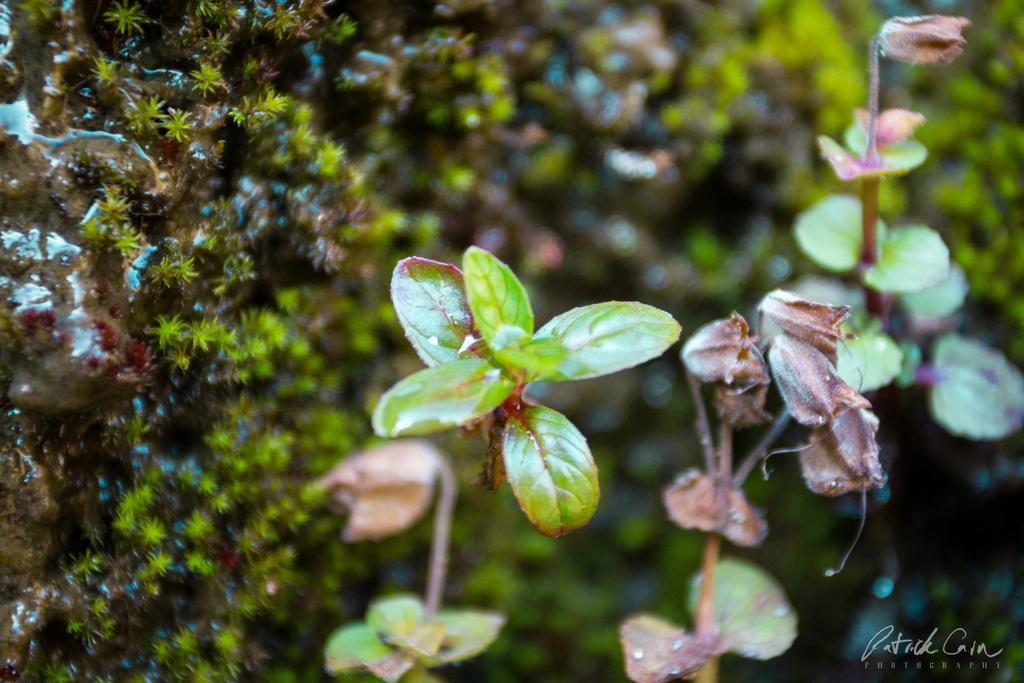Please provide a concise description of this image. In this picture we can see there are plants and there is moss on a rock. In the bottom right corner of the image, there is a watermark. 